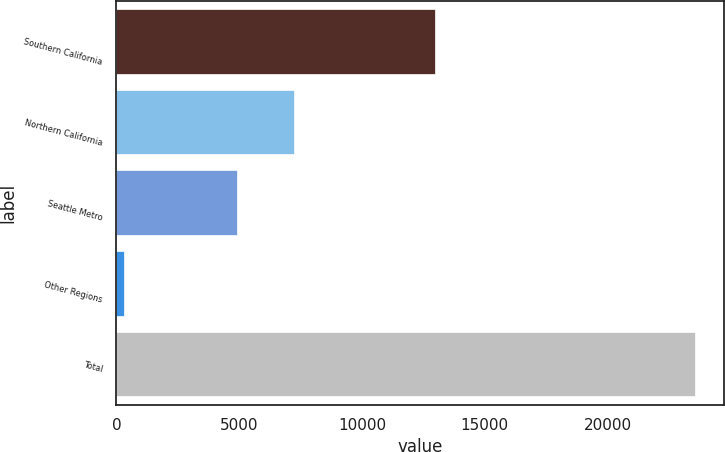<chart> <loc_0><loc_0><loc_500><loc_500><bar_chart><fcel>Southern California<fcel>Northern California<fcel>Seattle Metro<fcel>Other Regions<fcel>Total<nl><fcel>12965<fcel>7230.9<fcel>4905<fcel>302<fcel>23561<nl></chart> 